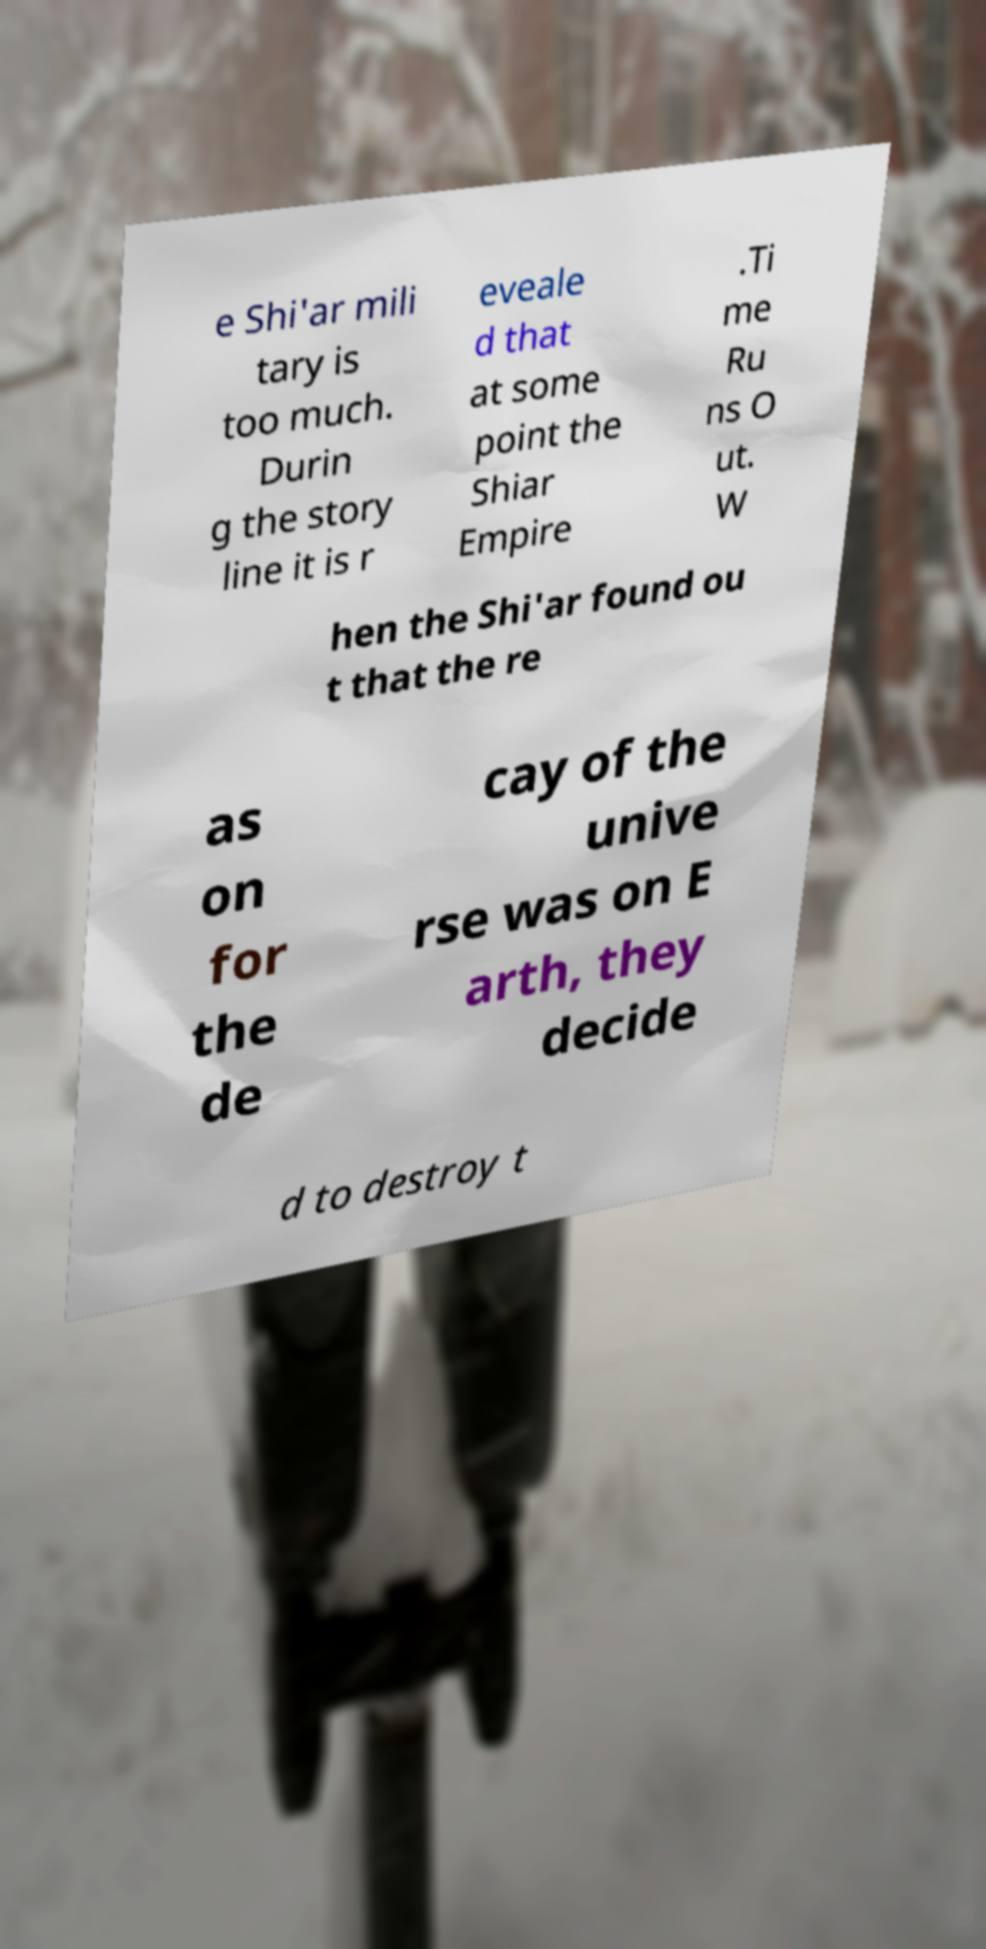Can you accurately transcribe the text from the provided image for me? e Shi'ar mili tary is too much. Durin g the story line it is r eveale d that at some point the Shiar Empire .Ti me Ru ns O ut. W hen the Shi'ar found ou t that the re as on for the de cay of the unive rse was on E arth, they decide d to destroy t 